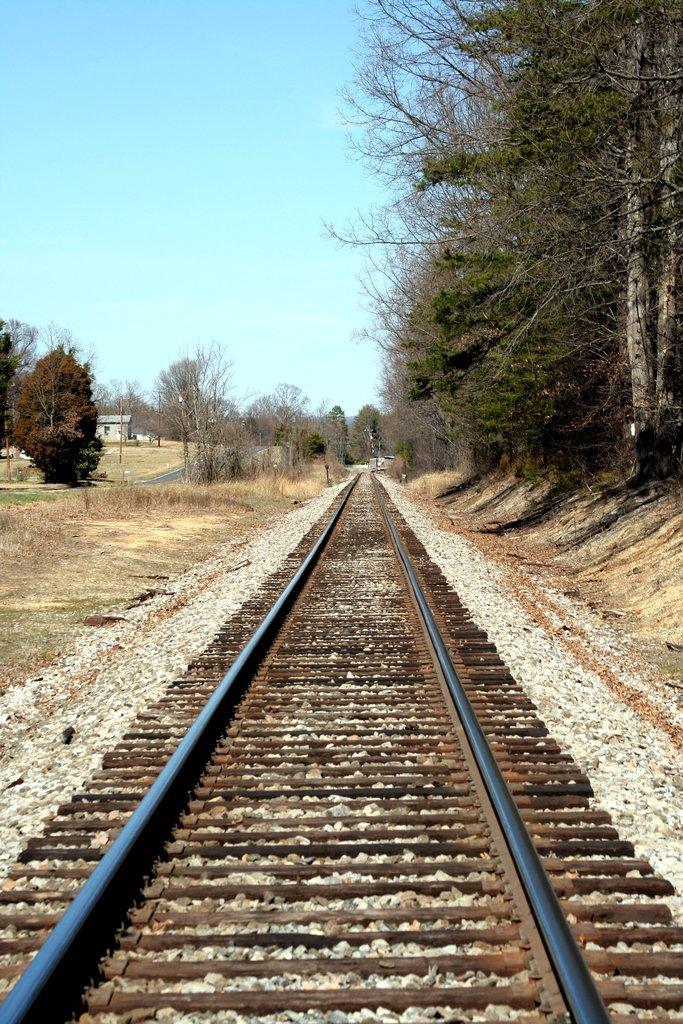In one or two sentences, can you explain what this image depicts? In the center of the image we can see the track. We can also see some stones, plants, grass, a group of trees, a house with a roof and the sky which looks cloudy. 